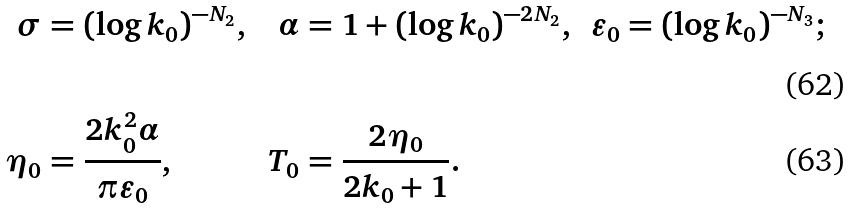<formula> <loc_0><loc_0><loc_500><loc_500>\sigma & = ( \log k _ { 0 } ) ^ { - N _ { 2 } } , & \alpha & = 1 + ( \log k _ { 0 } ) ^ { - 2 N _ { 2 } } , & \varepsilon _ { 0 } & = ( \log k _ { 0 } ) ^ { - N _ { 3 } } ; \\ \eta _ { 0 } & = \frac { 2 k _ { 0 } ^ { 2 } \alpha } { \pi \varepsilon _ { 0 } } , & T _ { 0 } & = \frac { 2 \eta _ { 0 } } { 2 k _ { 0 } + 1 } .</formula> 